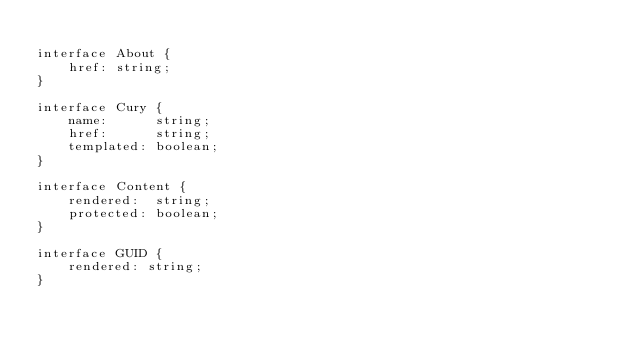Convert code to text. <code><loc_0><loc_0><loc_500><loc_500><_TypeScript_>
interface About {
    href: string;
}

interface Cury {
    name:      string;
    href:      string;
    templated: boolean;
}

interface Content {
    rendered:  string;
    protected: boolean;
}

interface GUID {
    rendered: string;
}
</code> 